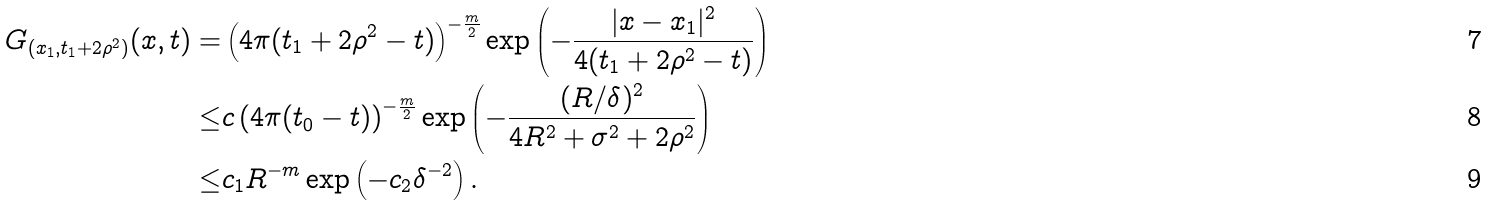<formula> <loc_0><loc_0><loc_500><loc_500>G _ { ( x _ { 1 } , t _ { 1 } + 2 \rho ^ { 2 } ) } ( x , t ) = & \left ( 4 \pi ( t _ { 1 } + 2 \rho ^ { 2 } - t ) \right ) ^ { - \frac { m } { 2 } } \exp \left ( - \frac { | x - x _ { 1 } | ^ { 2 } } { 4 ( t _ { 1 } + 2 \rho ^ { 2 } - t ) } \right ) \\ \leq & c \left ( 4 \pi ( t _ { 0 } - t ) \right ) ^ { - \frac { m } { 2 } } \exp \left ( - \frac { ( R / \delta ) ^ { 2 } } { 4 R ^ { 2 } + \sigma ^ { 2 } + 2 \rho ^ { 2 } } \right ) \\ \leq & c _ { 1 } R ^ { - m } \exp \left ( - c _ { 2 } \delta ^ { - 2 } \right ) .</formula> 